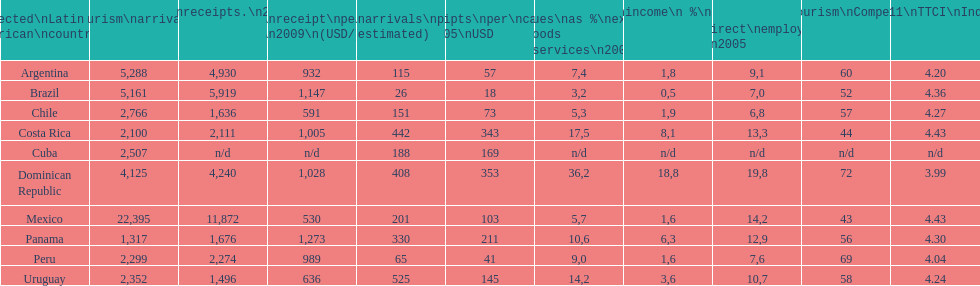What was the average amount of dollars brazil obtained per visitor in 2009? 1,147. 